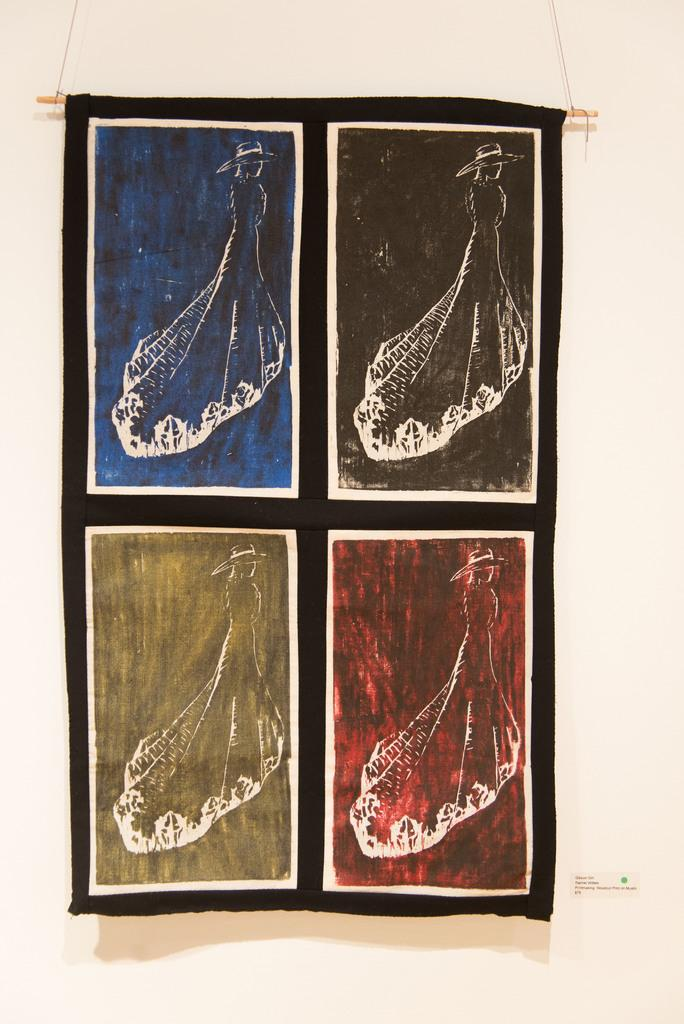What is the main subject in the center of the image? There is a cloth in the center of the image. What is depicted on the cloth? There is some art on the cloth. What can be seen in the background of the image? There is a wall in the background of the image. What type of bucket is used to collect thoughts in the image? There is no bucket or collection of thoughts present in the image. 